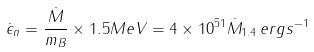<formula> <loc_0><loc_0><loc_500><loc_500>\dot { \epsilon } _ { n } = \frac { \dot { M } } { m _ { B } } \times 1 . 5 M e V = 4 \times 1 0 ^ { 5 1 } \dot { M } _ { 1 . 4 } \, e r g s ^ { - 1 }</formula> 